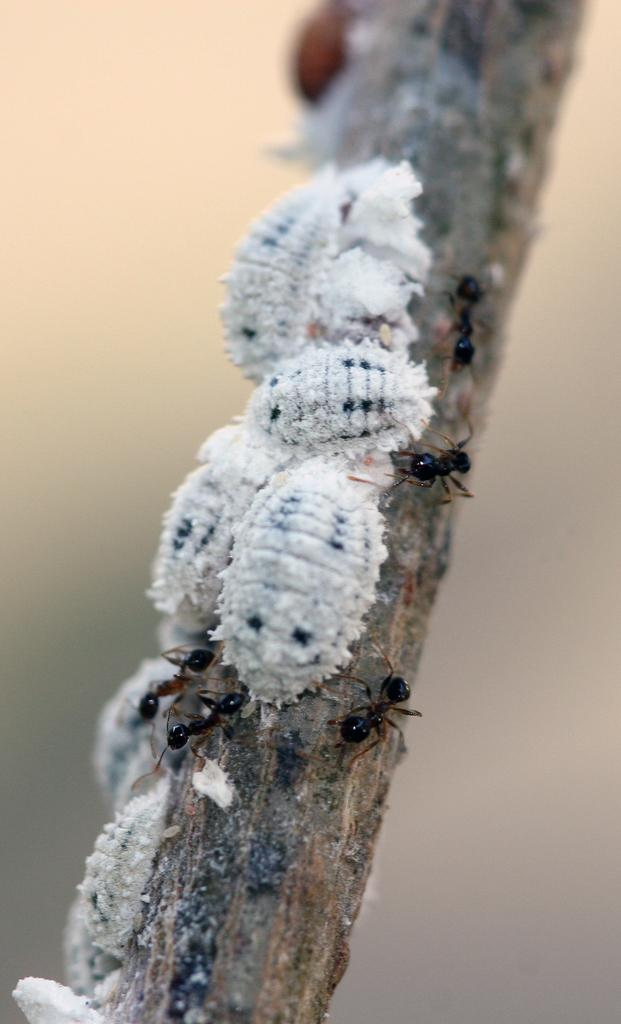What is the main object in the image? There is a stick in the image. What is present on the stick? There are ants and other insects on the stick. Can you describe the background of the image? The background of the image is blurred. What type of wave can be seen in the image? There is no wave present in the image; it features a stick with ants and other insects. What are the characters reading in the image? There are no characters or reading material present in the image. 